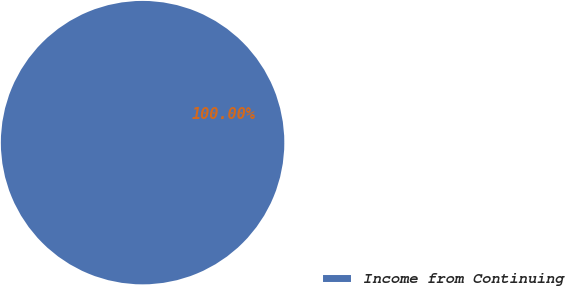Convert chart to OTSL. <chart><loc_0><loc_0><loc_500><loc_500><pie_chart><fcel>Income from Continuing<nl><fcel>100.0%<nl></chart> 